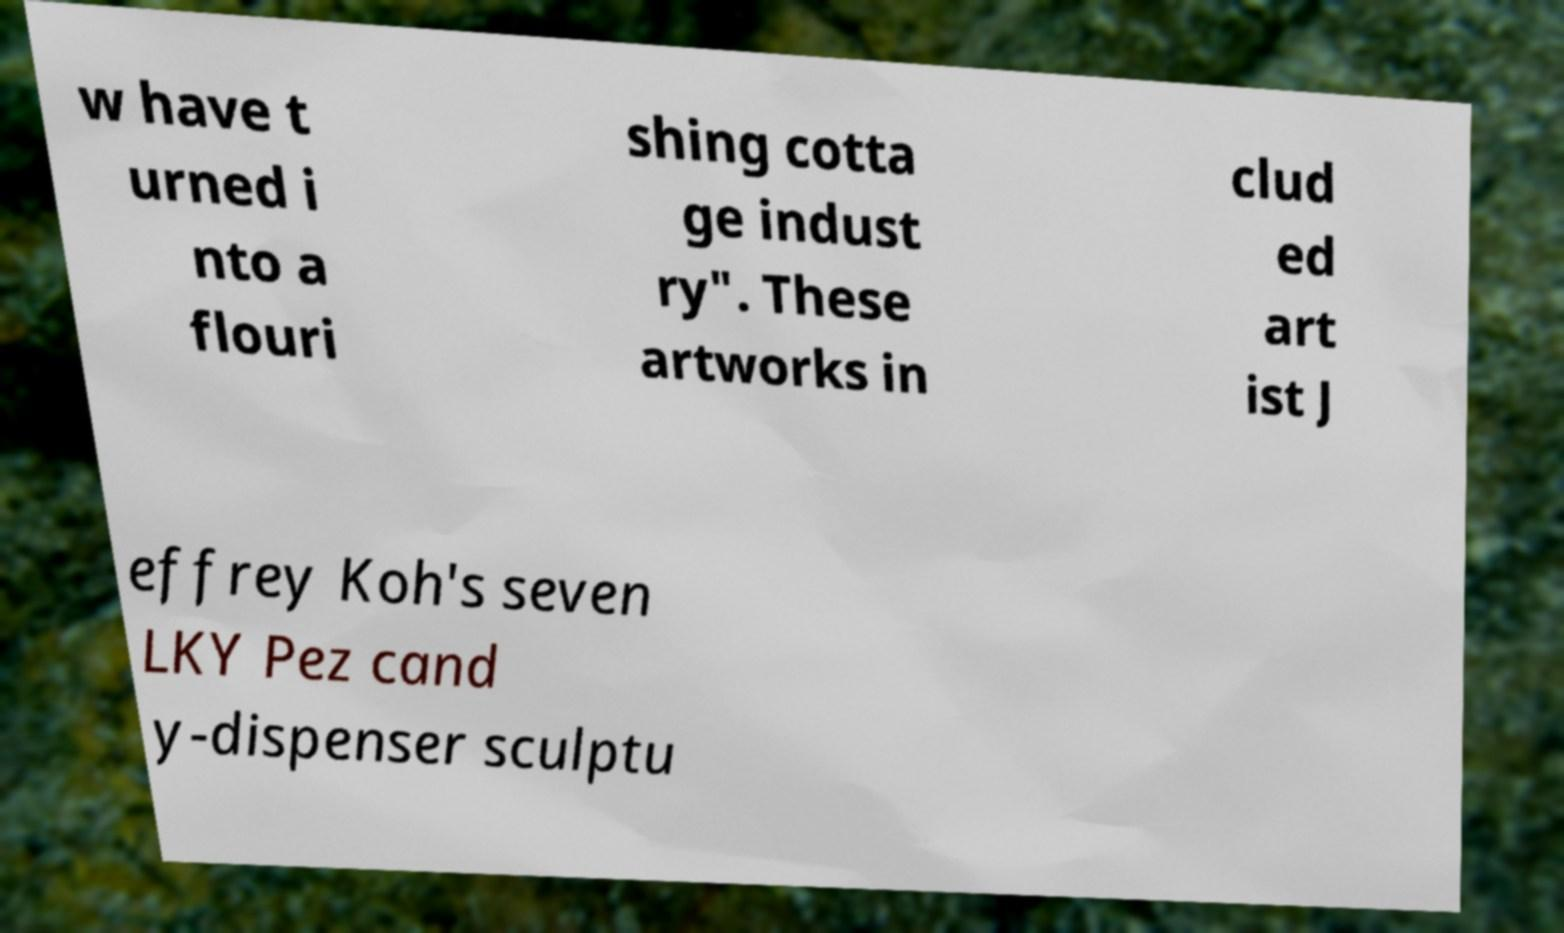Can you read and provide the text displayed in the image?This photo seems to have some interesting text. Can you extract and type it out for me? w have t urned i nto a flouri shing cotta ge indust ry". These artworks in clud ed art ist J effrey Koh's seven LKY Pez cand y-dispenser sculptu 